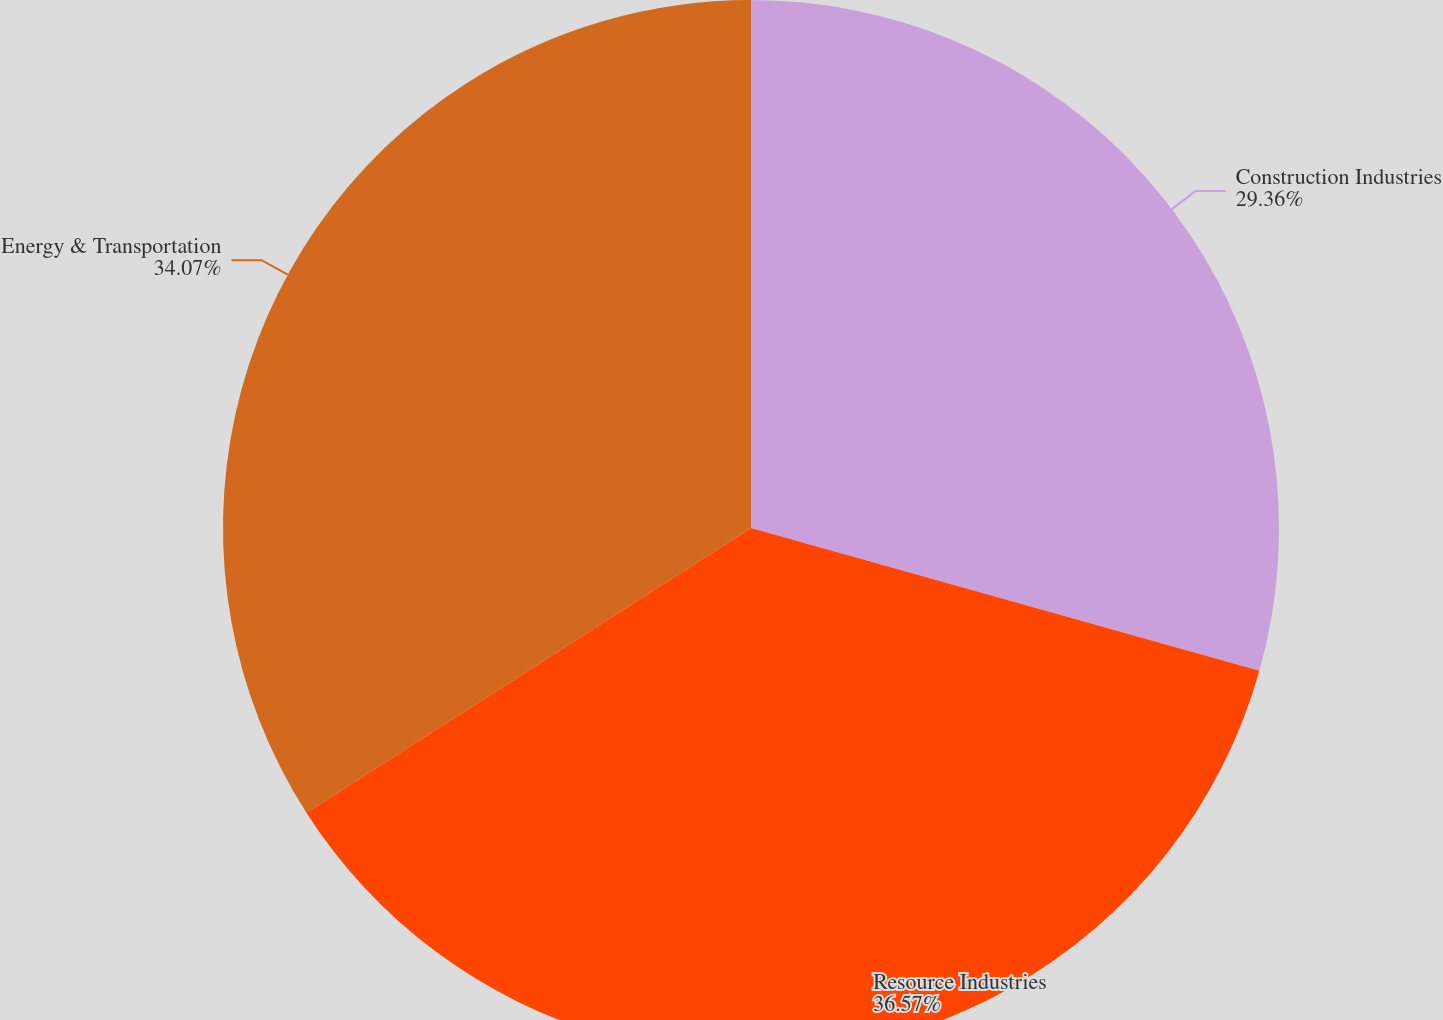Convert chart to OTSL. <chart><loc_0><loc_0><loc_500><loc_500><pie_chart><fcel>Construction Industries<fcel>Resource Industries<fcel>Energy & Transportation<nl><fcel>29.36%<fcel>36.58%<fcel>34.07%<nl></chart> 